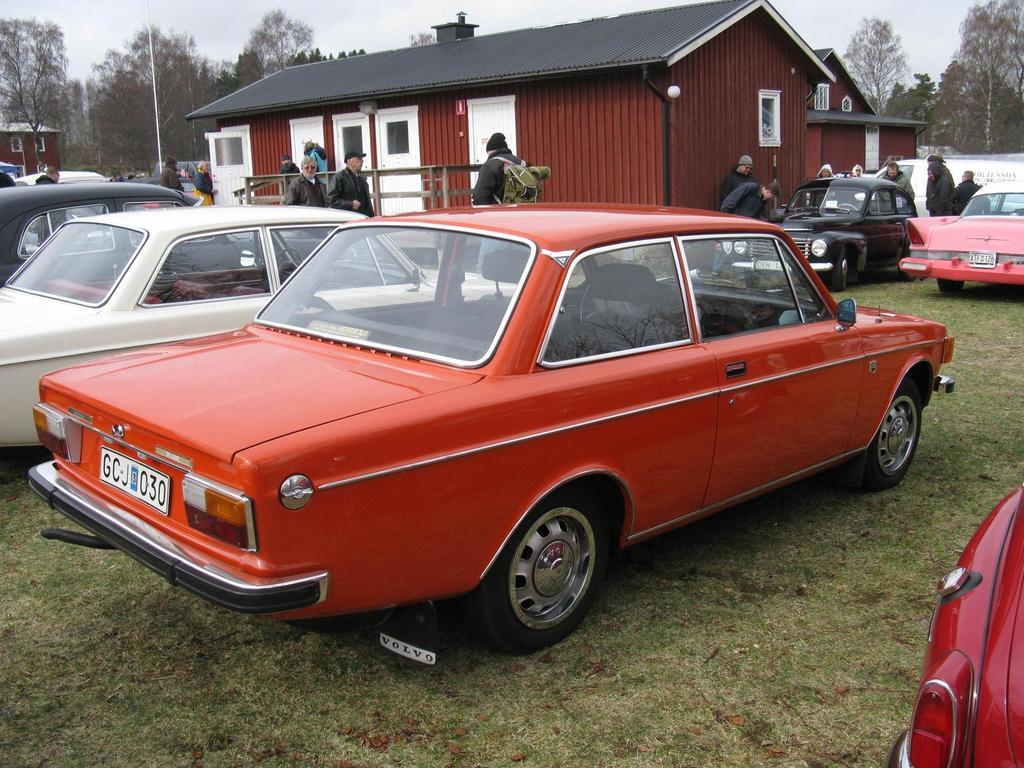What type of vehicles can be seen in the image? There are cars in the image. Who or what else is present in the image besides the cars? There are people in the image, and they are on the grass. What can be seen in the background of the image? There are houses, a pole, and trees in the background of the image. What is visible at the top of the image? The sky is visible at the top of the image. What type of goose can be seen singing in the image? There is no goose present in the image, let alone one singing. How does the acoustics of the image affect the sound of the people's voices? The image does not provide any information about the acoustics or the sound of the people's voices. 